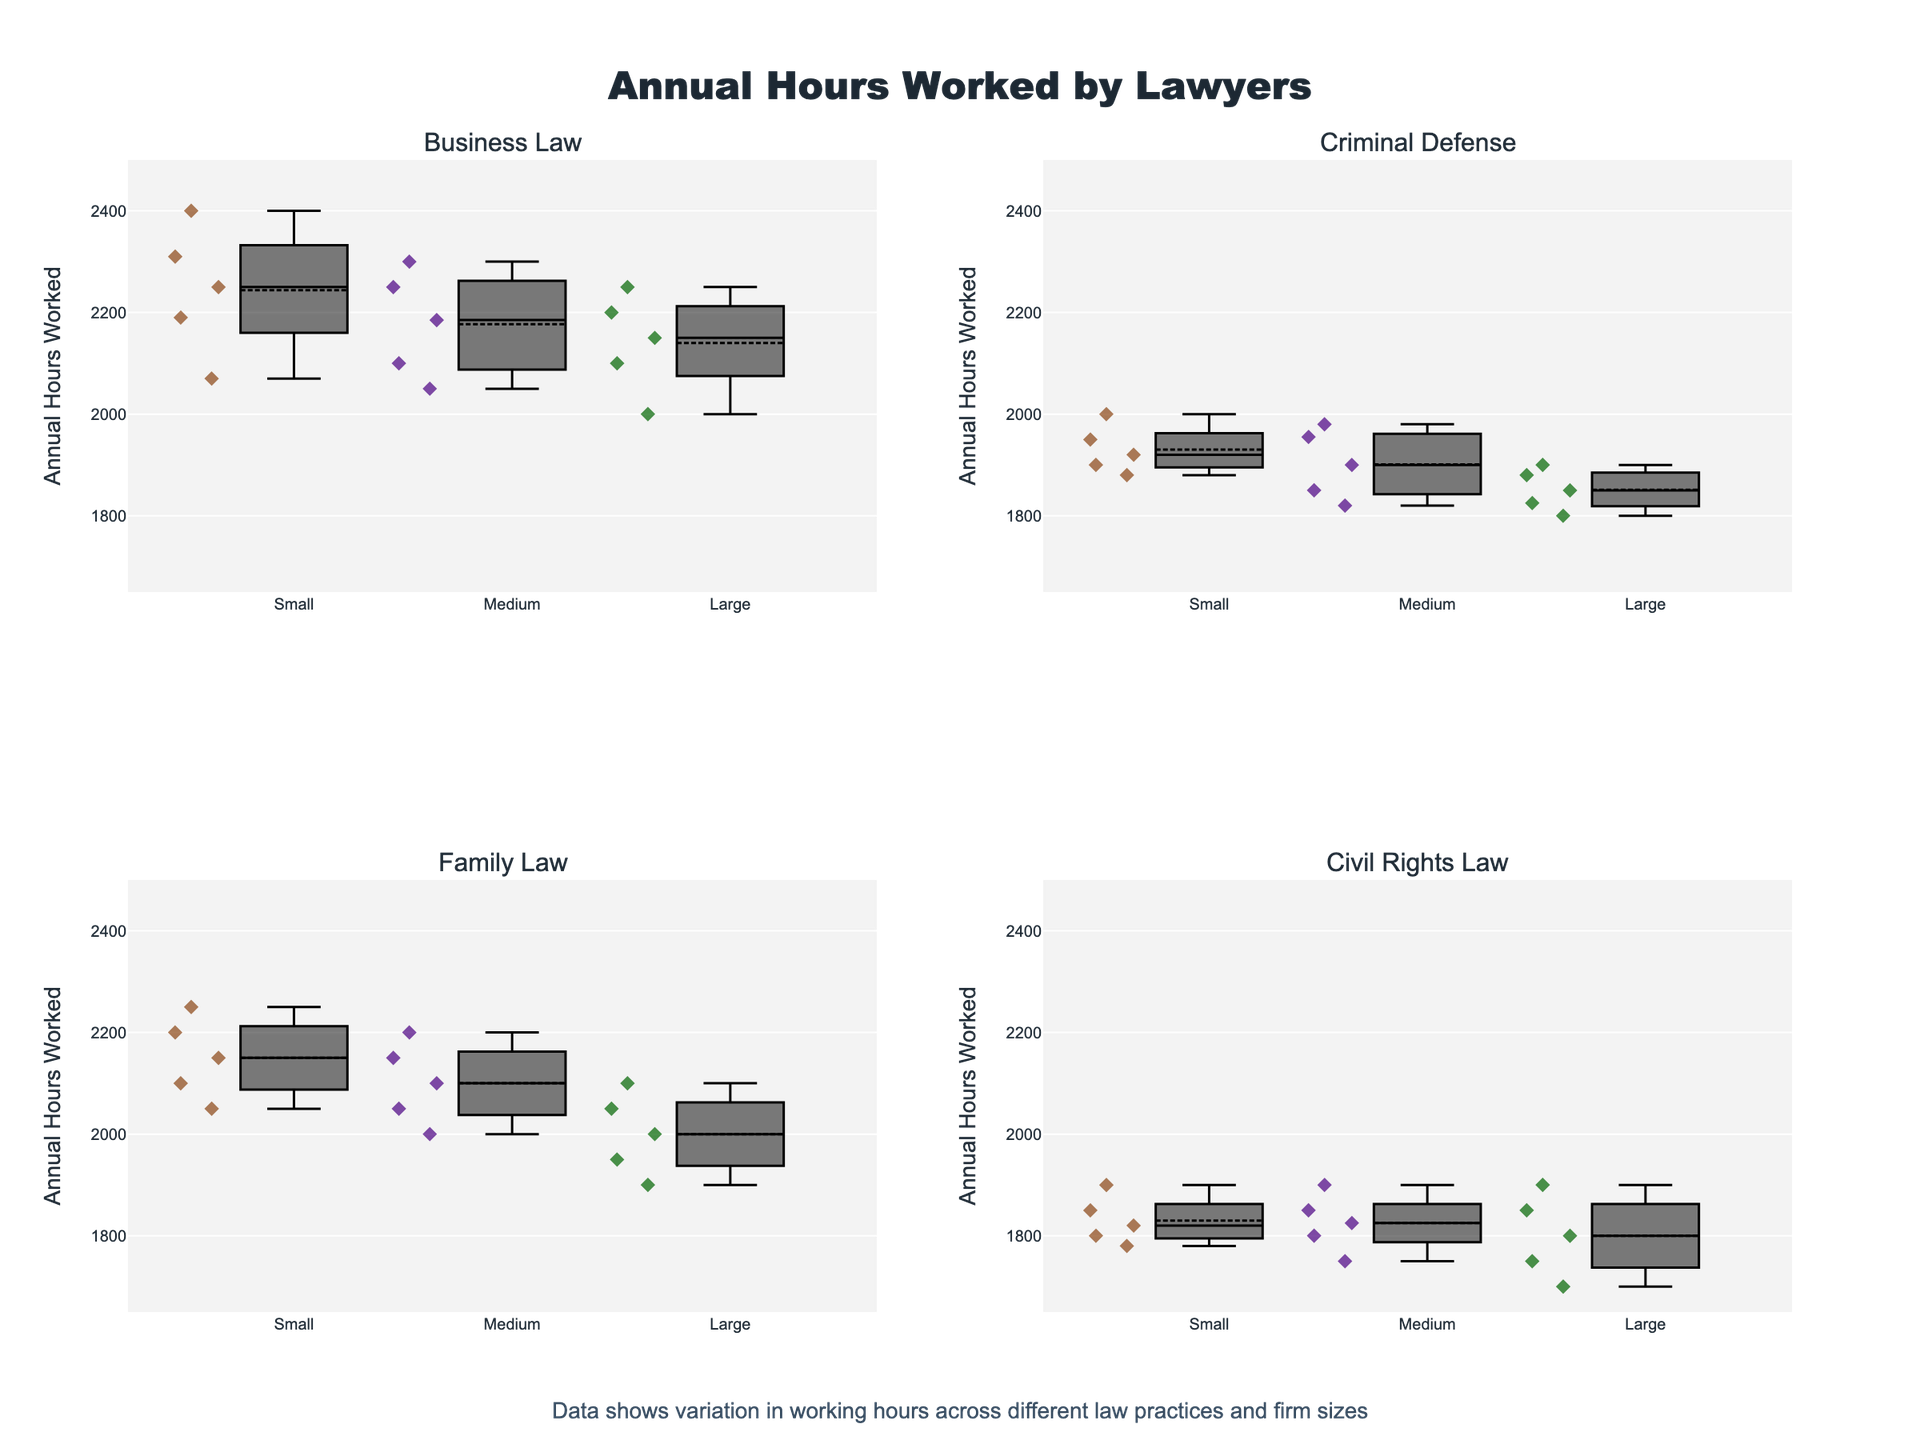What is the title of the figure? The title of the figure can be found at the top of the plot. It reads "Annual Hours Worked by Lawyers".
Answer: Annual Hours Worked by Lawyers Which type of law has the highest median annual hours worked for small firms? To find the median annual hours worked for small firms, look at the middle line of each box plot corresponding to small firms across all subplots. The highest median value appears in the Business Law plot.
Answer: Business Law Which firm size in Civil Rights Law has the lowest range of annual hours worked? The range of a box plot is the distance between the upper and lower whiskers. For Civil Rights Law, small and medium firms have similar ranges, but large firms have a narrower range between approximately 1700 and 1900 hours.
Answer: Large What is the range of annual hours worked for medium-sized firms in Family Law? Examine the spread from the lower to upper whiskers for Family Law regarding medium firms. It ranges from about 2000 to 2200 annual hours.
Answer: 2000 to 2200 Comparing Business Law and Criminal Defense for medium-sized firms, which practice has a higher median annual hours worked? Look at the middle line of each box plot for medium-sized firms in Business Law and Criminal Defense. Business Law shows a higher median value.
Answer: Business Law Which type of law practiced in large firms shows the most variability in annual hours worked? Variability in box plots is indicated by the length of the box itself and the whiskers. For large firms, the Business Law box plot shows the widest spread, which means it has the most variability.
Answer: Business Law How do the median annual hours worked in Family Law compare between small and large firms? Compare the middle lines in the box plots for Family Law between small and large firms. Small firms have a higher median at around 2150 hours, whereas large firms have a lower median around 2000 hours.
Answer: Small firms have a higher median What is the box color used for medium-sized firms? The color used for medium-sized firms can be seen consistently across all subplots as a dark purple.
Answer: Dark purple Is the statement "Criminal defense lawyers work fewer hours in large firms compared to small firms" supported by the figure? Compare the box plots for Criminal Defense between small and large firms. The median and the overall range for large firms are lower compared to those for small firms.
Answer: Yes In which type of law do small firms have the closest interquartile range (IQR) values compared to large firms? The IQR for each box plot is the distance between the lower and upper quartiles. Compare the IQR of small and large firms across all types of law. In Family Law, the IQRs appear to be the most similar.
Answer: Family Law 